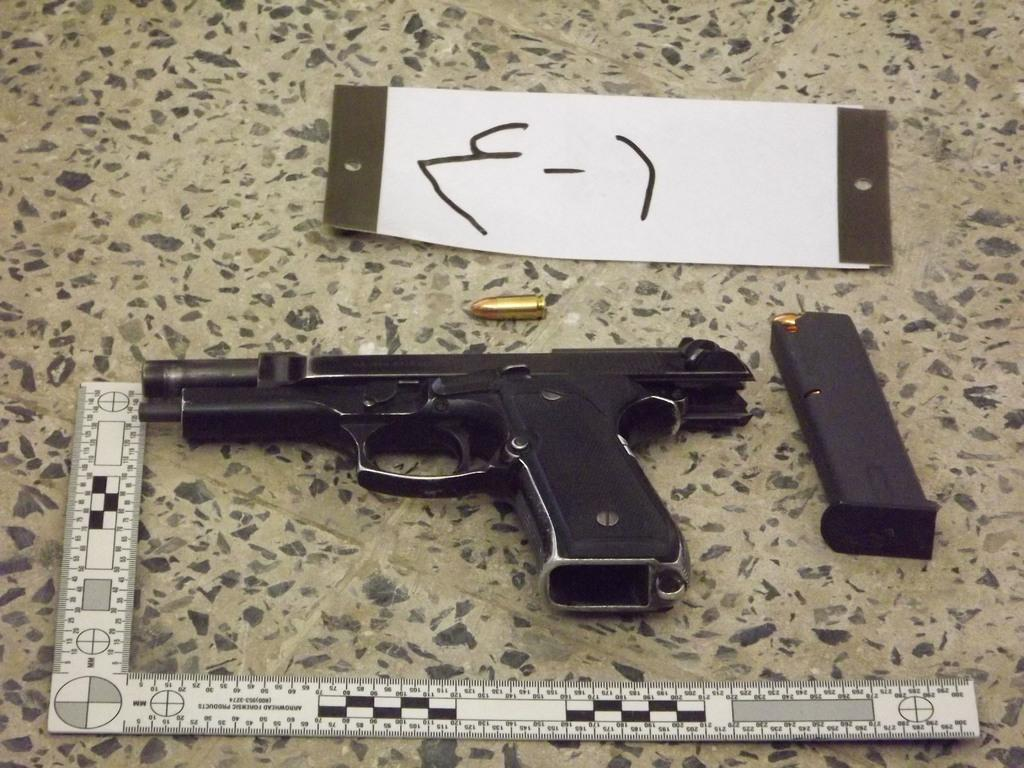What type of weapon is present in the image? There is a gun in the image. What is related to the gun that can also be seen in the image? There is a bullet shell and a bullet in the image. What is the flat, rectangular object in the image? There is a board in the image. What is the measuring device placed on the floor in the image? There is a scale placed on the floor in the image. Where is the crate of coal located in the image? There is no crate of coal present in the image. What type of glue is being used to attach the bullet to the board in the image? There is no glue or attachment of the bullet to the board in the image; the bullet is separate from the board. 